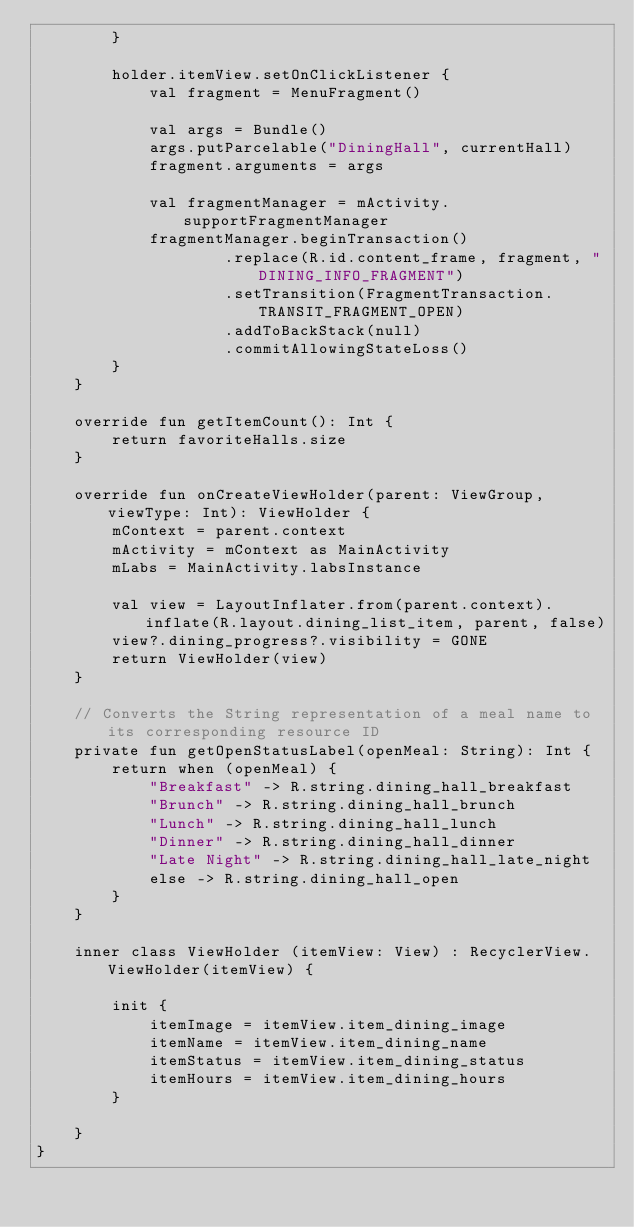<code> <loc_0><loc_0><loc_500><loc_500><_Kotlin_>        }

        holder.itemView.setOnClickListener {
            val fragment = MenuFragment()

            val args = Bundle()
            args.putParcelable("DiningHall", currentHall)
            fragment.arguments = args

            val fragmentManager = mActivity.supportFragmentManager
            fragmentManager.beginTransaction()
                    .replace(R.id.content_frame, fragment, "DINING_INFO_FRAGMENT")
                    .setTransition(FragmentTransaction.TRANSIT_FRAGMENT_OPEN)
                    .addToBackStack(null)
                    .commitAllowingStateLoss()
        }
    }

    override fun getItemCount(): Int {
        return favoriteHalls.size
    }

    override fun onCreateViewHolder(parent: ViewGroup, viewType: Int): ViewHolder {
        mContext = parent.context
        mActivity = mContext as MainActivity
        mLabs = MainActivity.labsInstance

        val view = LayoutInflater.from(parent.context).inflate(R.layout.dining_list_item, parent, false)
        view?.dining_progress?.visibility = GONE
        return ViewHolder(view)
    }

    // Converts the String representation of a meal name to its corresponding resource ID
    private fun getOpenStatusLabel(openMeal: String): Int {
        return when (openMeal) {
            "Breakfast" -> R.string.dining_hall_breakfast
            "Brunch" -> R.string.dining_hall_brunch
            "Lunch" -> R.string.dining_hall_lunch
            "Dinner" -> R.string.dining_hall_dinner
            "Late Night" -> R.string.dining_hall_late_night
            else -> R.string.dining_hall_open
        }
    }

    inner class ViewHolder (itemView: View) : RecyclerView.ViewHolder(itemView) {

        init {
            itemImage = itemView.item_dining_image
            itemName = itemView.item_dining_name
            itemStatus = itemView.item_dining_status
            itemHours = itemView.item_dining_hours
        }

    }
}
</code> 